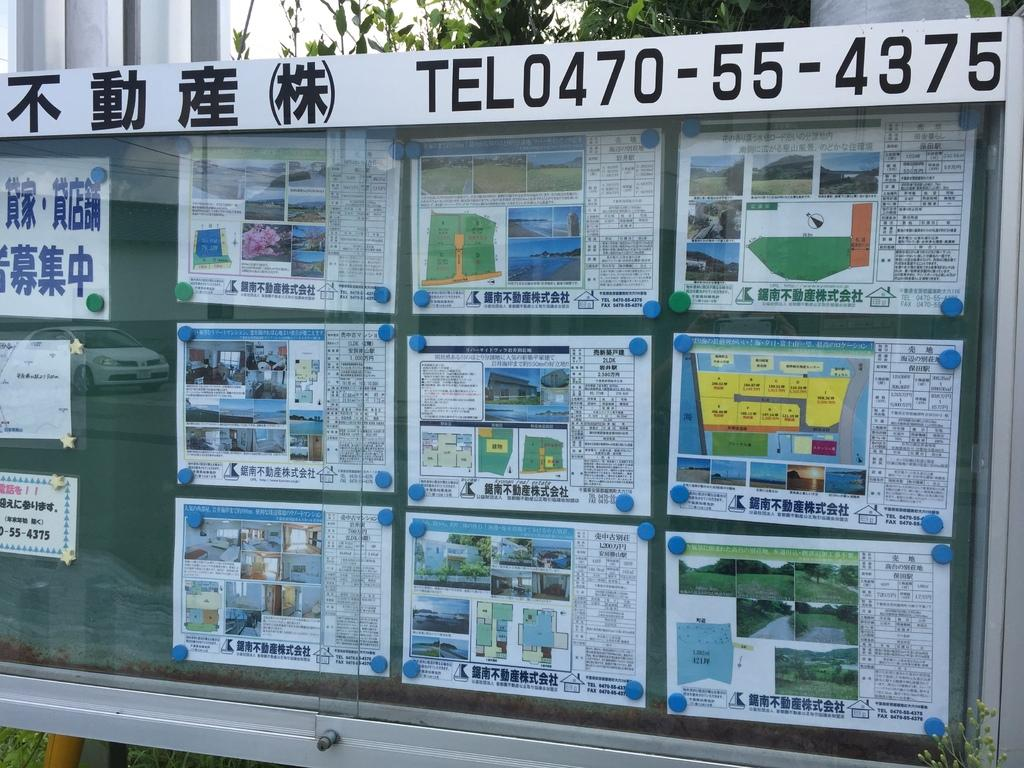<image>
Create a compact narrative representing the image presented. To find out about these homes for sale one should call 0470-55-4375. 